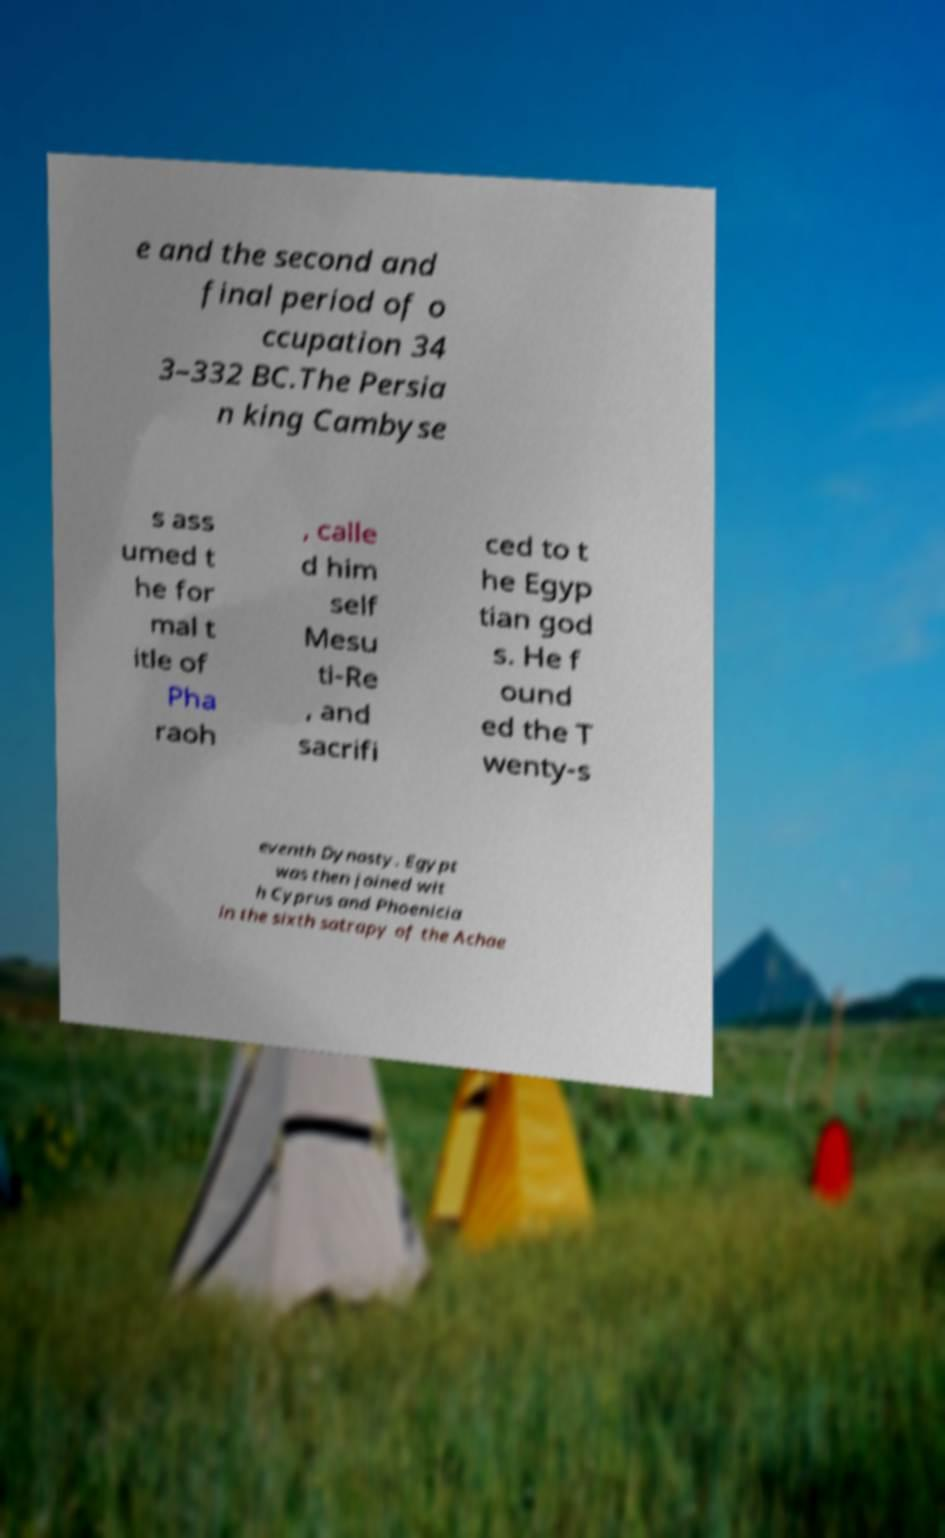Could you extract and type out the text from this image? e and the second and final period of o ccupation 34 3–332 BC.The Persia n king Cambyse s ass umed t he for mal t itle of Pha raoh , calle d him self Mesu ti-Re , and sacrifi ced to t he Egyp tian god s. He f ound ed the T wenty-s eventh Dynasty. Egypt was then joined wit h Cyprus and Phoenicia in the sixth satrapy of the Achae 